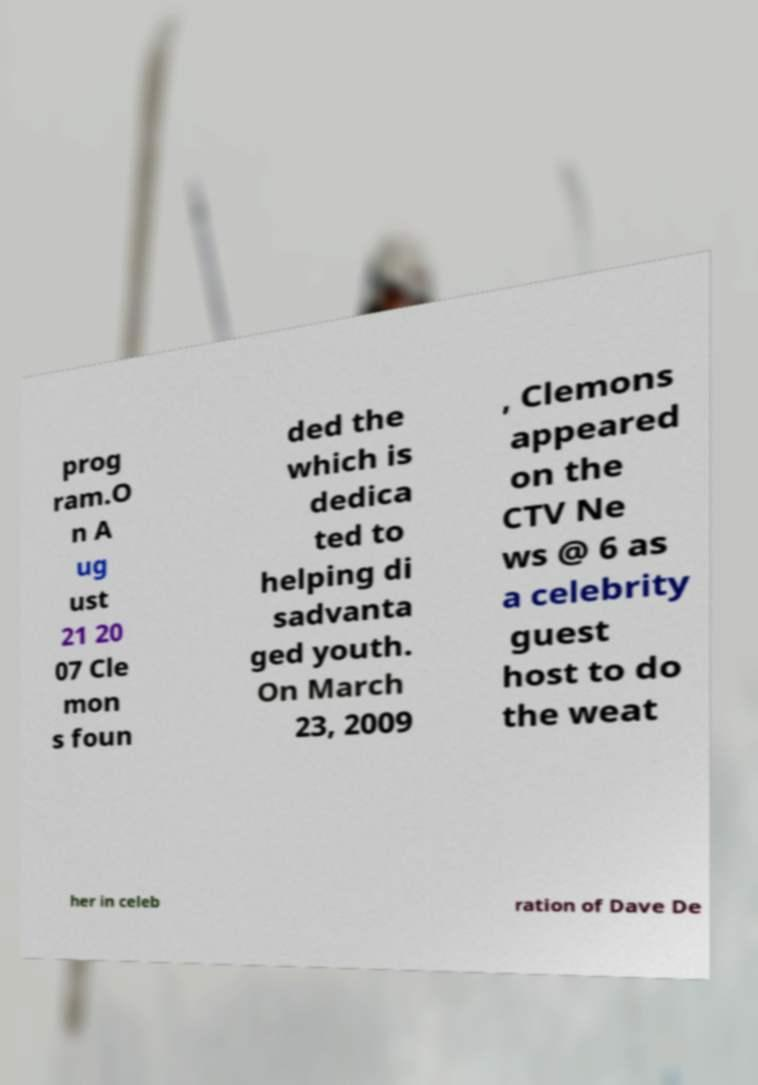What messages or text are displayed in this image? I need them in a readable, typed format. prog ram.O n A ug ust 21 20 07 Cle mon s foun ded the which is dedica ted to helping di sadvanta ged youth. On March 23, 2009 , Clemons appeared on the CTV Ne ws @ 6 as a celebrity guest host to do the weat her in celeb ration of Dave De 